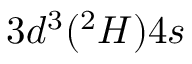Convert formula to latex. <formula><loc_0><loc_0><loc_500><loc_500>3 d ^ { 3 } ( ^ { 2 } H ) 4 s</formula> 